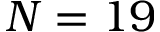<formula> <loc_0><loc_0><loc_500><loc_500>N = 1 9</formula> 